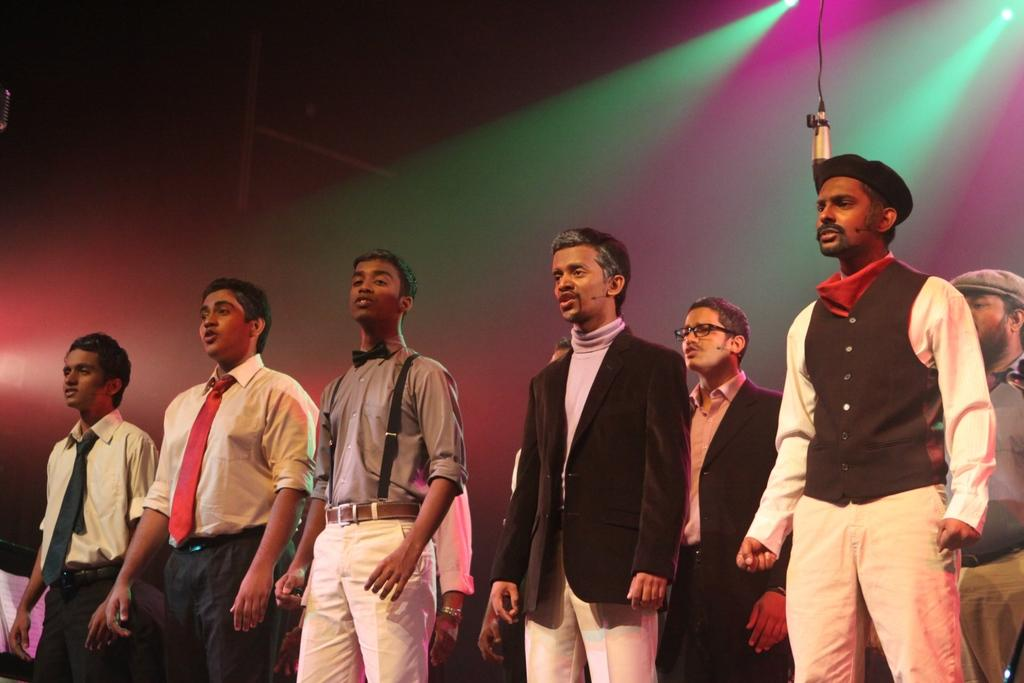What is happening in the image involving a group of men? The men are performing a drama, as they are standing on a stage. What can be seen in the background of the image? There are green spotlights visible in the image. What is the setting for the performance in the image? The men are performing on a stage. What type of cabbage is being used as a prop in the image? There is no cabbage present in the image; it features a group of men performing a drama on a stage. What color is the curtain behind the men in the image? The provided facts do not mention a curtain behind the men, so we cannot determine its color. 